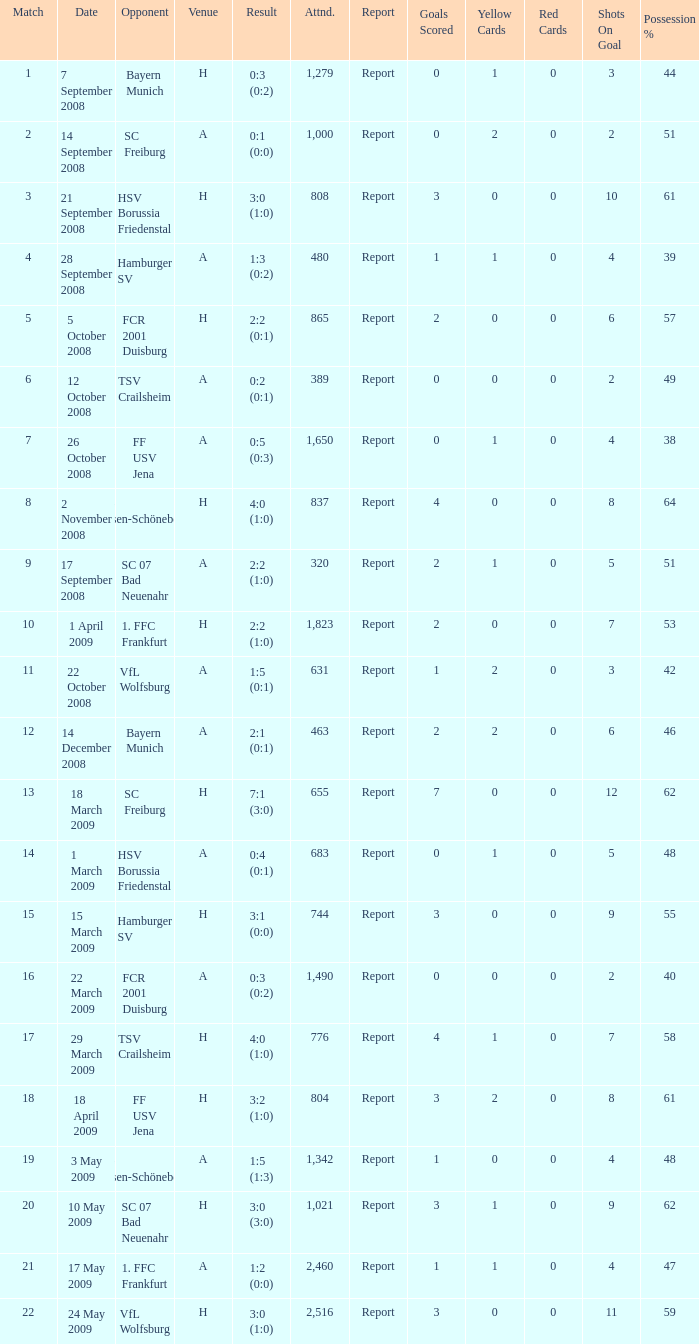Which match did FCR 2001 Duisburg participate as the opponent? 21.0. 